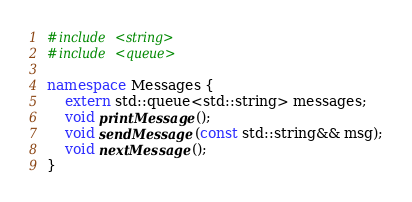Convert code to text. <code><loc_0><loc_0><loc_500><loc_500><_C++_>
#include <string>
#include <queue>

namespace Messages {
	extern std::queue<std::string> messages;
	void printMessage();
	void sendMessage(const std::string&& msg);
	void nextMessage();
}
</code> 